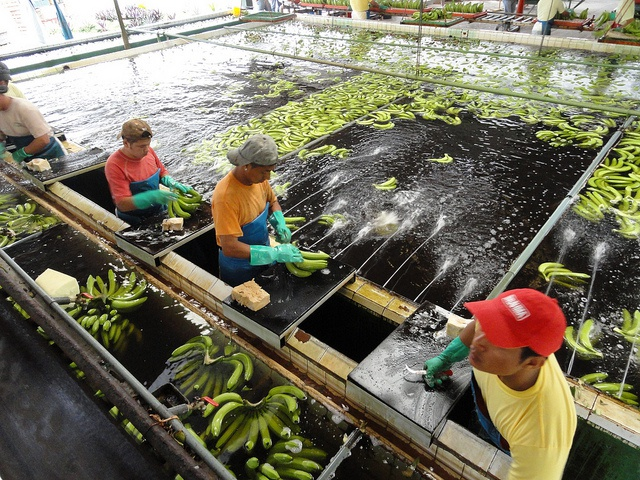Describe the objects in this image and their specific colors. I can see banana in white, black, olive, darkgreen, and gray tones, people in white, tan, brown, and khaki tones, people in white, red, black, maroon, and gray tones, people in white, black, salmon, and brown tones, and banana in white, black, and olive tones in this image. 